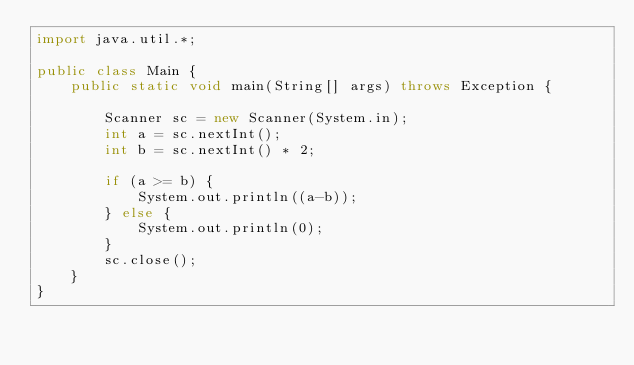Convert code to text. <code><loc_0><loc_0><loc_500><loc_500><_Java_>import java.util.*;

public class Main {
    public static void main(String[] args) throws Exception {
        
        Scanner sc = new Scanner(System.in);
        int a = sc.nextInt();
        int b = sc.nextInt() * 2;

        if (a >= b) {
            System.out.println((a-b));
        } else {
            System.out.println(0);
        }
        sc.close();
    }    
}
</code> 